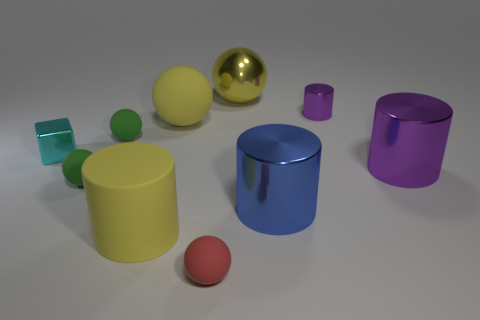Is there a gray matte sphere of the same size as the red rubber ball? no 